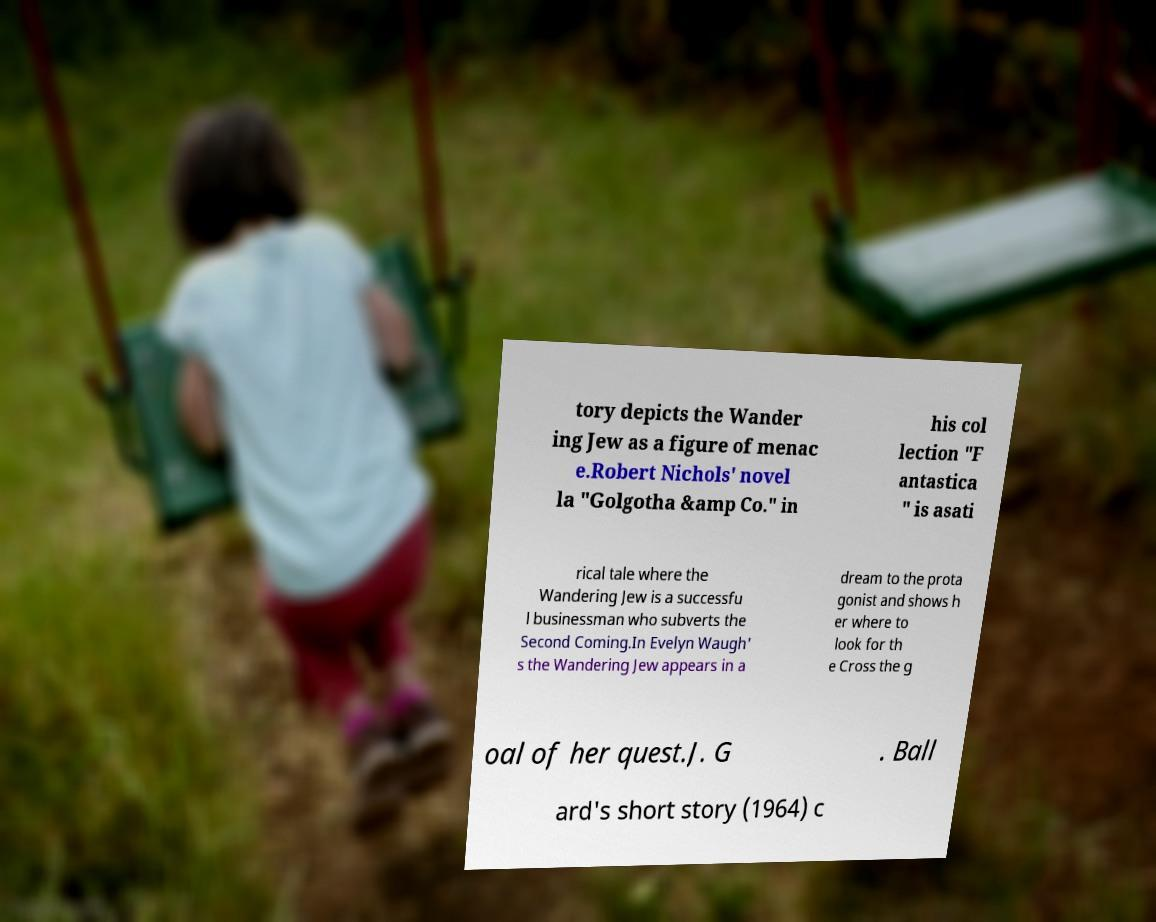Could you extract and type out the text from this image? tory depicts the Wander ing Jew as a figure of menac e.Robert Nichols' novel la "Golgotha &amp Co." in his col lection "F antastica " is asati rical tale where the Wandering Jew is a successfu l businessman who subverts the Second Coming.In Evelyn Waugh' s the Wandering Jew appears in a dream to the prota gonist and shows h er where to look for th e Cross the g oal of her quest.J. G . Ball ard's short story (1964) c 